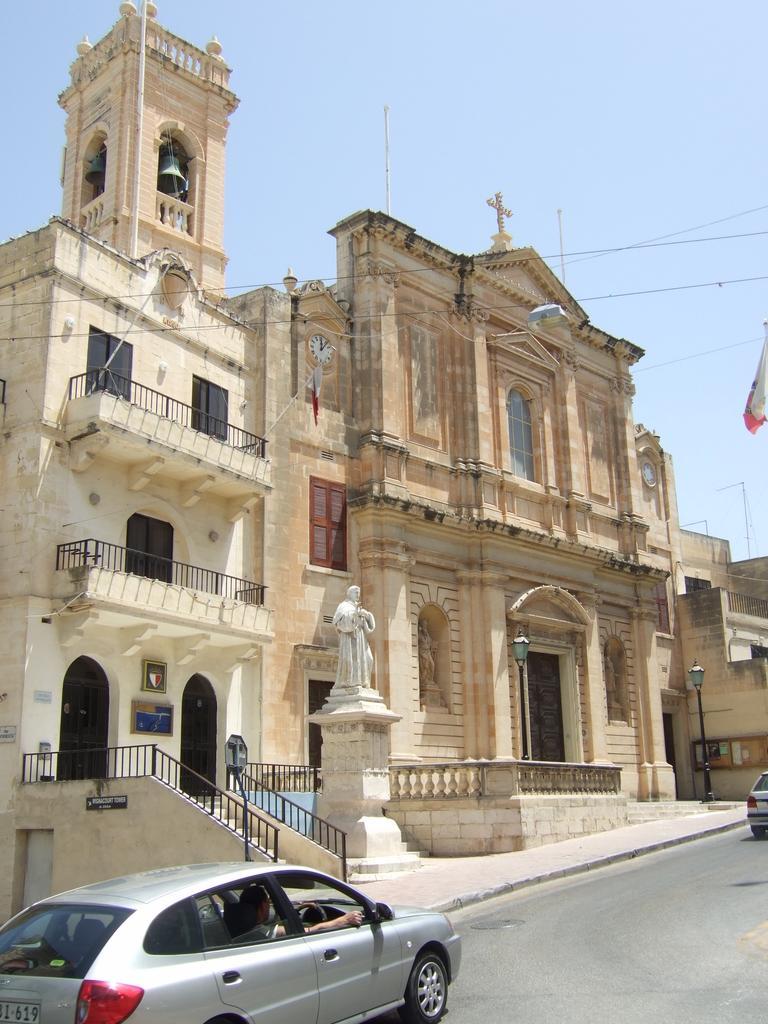In one or two sentences, can you explain what this image depicts? In the image we can see buildings and windows of the buildings. We can even see vehicles on the road, here we can see the fences, stairs and electric wires. We can even see sculpture, cross symbol and the sky. 